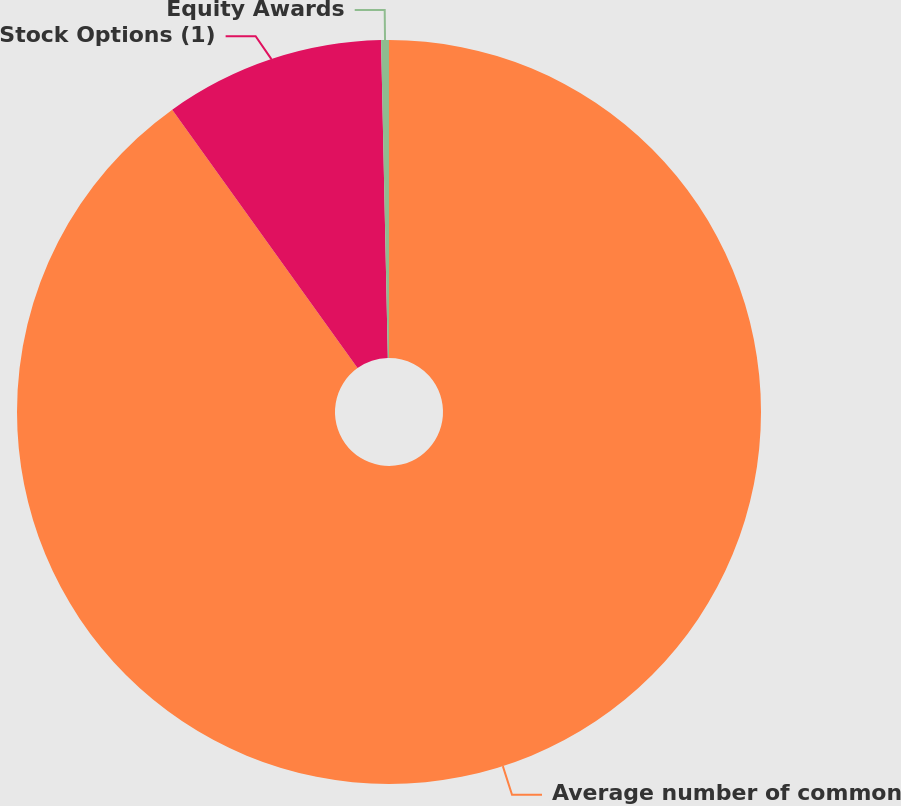Convert chart. <chart><loc_0><loc_0><loc_500><loc_500><pie_chart><fcel>Average number of common<fcel>Stock Options (1)<fcel>Equity Awards<nl><fcel>90.1%<fcel>9.56%<fcel>0.34%<nl></chart> 